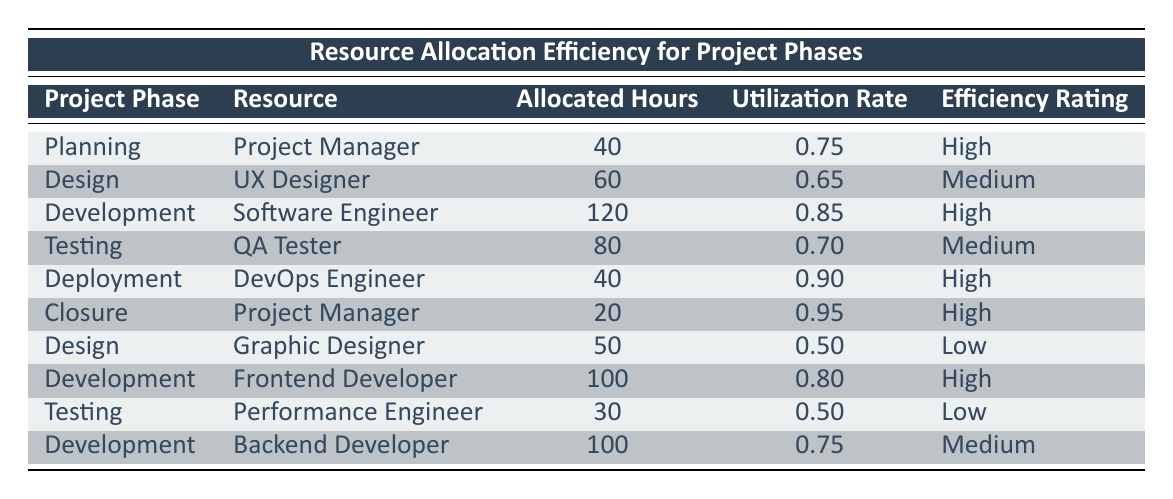What is the utilization rate for the DevOps Engineer in the Deployment phase? The table shows that the allocated hours for the DevOps Engineer in the Deployment phase is 40 and the utilization rate is 0.90. Therefore, the utilization rate is directly extracted from the corresponding row.
Answer: 0.90 Which project phase has the lowest efficiency rating? The table shows that the Graphic Designer in the Design phase and the Performance Engineer in the Testing phase both have a low efficiency rating. However, there are no other resources listed with a low rating. This means that the lowest efficiency ratings belong to these two resources.
Answer: Graphic Designer and Performance Engineer What is the total allocated hours for all the Testing phase resources? In the Testing phase, the QA Tester has allocated 80 hours and the Performance Engineer has allocated 30 hours. Adding these values together gives 80 + 30 = 110 hours, which represents the total allocated hours for the Testing phase resources.
Answer: 110 Is the utilization rate for the Software Engineer in the Development phase higher than 0.80? The utilization rate for the Software Engineer in the Development phase is 0.85, which is indeed higher than 0.80. This can be confirmed by directly referring to the relevant row in the table.
Answer: Yes What is the overall average utilization rate for the Development phase? In the Development phase, the Software Engineer has a utilization rate of 0.85, the Frontend Developer has a utilization rate of 0.80, and the Backend Developer has a utilization rate of 0.75. To find the average, we sum these rates, which is 0.85 + 0.80 + 0.75 = 2.40. Dividing this by 3 (the number of entries in this phase) gives an average of 2.40 / 3 = 0.80.
Answer: 0.80 